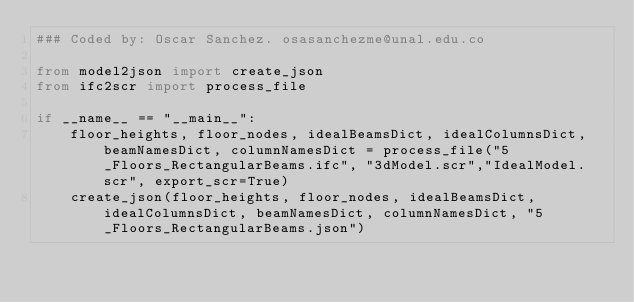<code> <loc_0><loc_0><loc_500><loc_500><_Python_>### Coded by: Oscar Sanchez. osasanchezme@unal.edu.co

from model2json import create_json
from ifc2scr import process_file

if __name__ == "__main__":
    floor_heights, floor_nodes, idealBeamsDict, idealColumnsDict, beamNamesDict, columnNamesDict = process_file("5_Floors_RectangularBeams.ifc", "3dModel.scr","IdealModel.scr", export_scr=True)
    create_json(floor_heights, floor_nodes, idealBeamsDict, idealColumnsDict, beamNamesDict, columnNamesDict, "5_Floors_RectangularBeams.json")</code> 